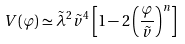Convert formula to latex. <formula><loc_0><loc_0><loc_500><loc_500>V ( \varphi ) \simeq \tilde { \lambda } ^ { 2 } \tilde { v } ^ { 4 } \left [ 1 - 2 \left ( \frac { \varphi } { \tilde { v } } \right ) ^ { n } \right ]</formula> 